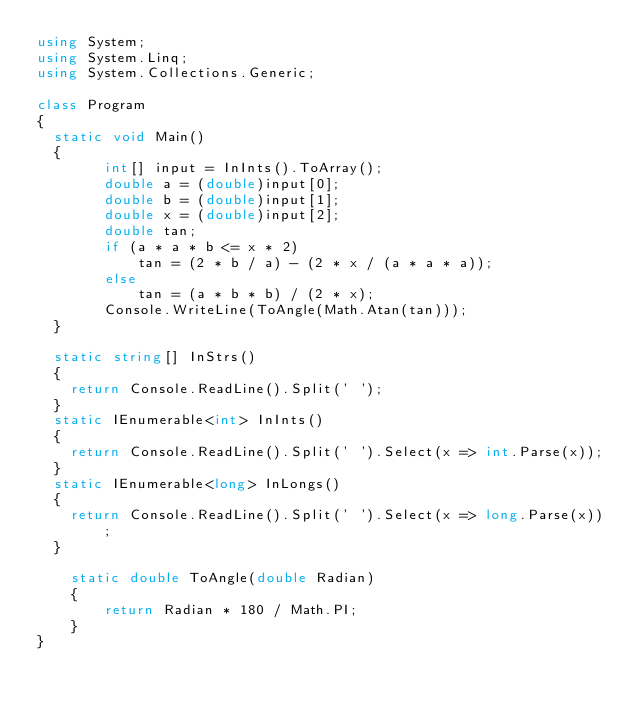Convert code to text. <code><loc_0><loc_0><loc_500><loc_500><_C#_>using System;
using System.Linq;
using System.Collections.Generic;

class Program
{
	static void Main()
	{
        int[] input = InInts().ToArray();
        double a = (double)input[0];
        double b = (double)input[1];
        double x = (double)input[2];
        double tan;
        if (a * a * b <= x * 2)
            tan = (2 * b / a) - (2 * x / (a * a * a));
        else
            tan = (a * b * b) / (2 * x);
        Console.WriteLine(ToAngle(Math.Atan(tan)));
	}

	static string[] InStrs()
	{
		return Console.ReadLine().Split(' ');
	}
	static IEnumerable<int> InInts()
	{
		return Console.ReadLine().Split(' ').Select(x => int.Parse(x));
	}
	static IEnumerable<long> InLongs()
	{
		return Console.ReadLine().Split(' ').Select(x => long.Parse(x));
	}

    static double ToAngle(double Radian)
    {
        return Radian * 180 / Math.PI;
    }
}</code> 